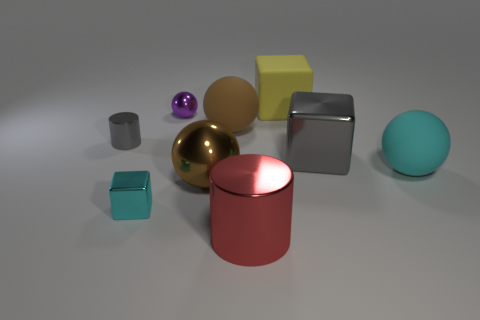Subtract all tiny cubes. How many cubes are left? 2 Subtract all cylinders. How many objects are left? 7 Subtract 1 blocks. How many blocks are left? 2 Subtract all purple balls. How many balls are left? 3 Add 1 matte objects. How many objects exist? 10 Subtract all blue blocks. Subtract all cyan cylinders. How many blocks are left? 3 Subtract all blue cubes. How many brown spheres are left? 2 Subtract all large gray metallic objects. Subtract all small cyan cubes. How many objects are left? 7 Add 9 cyan cubes. How many cyan cubes are left? 10 Add 1 metal cubes. How many metal cubes exist? 3 